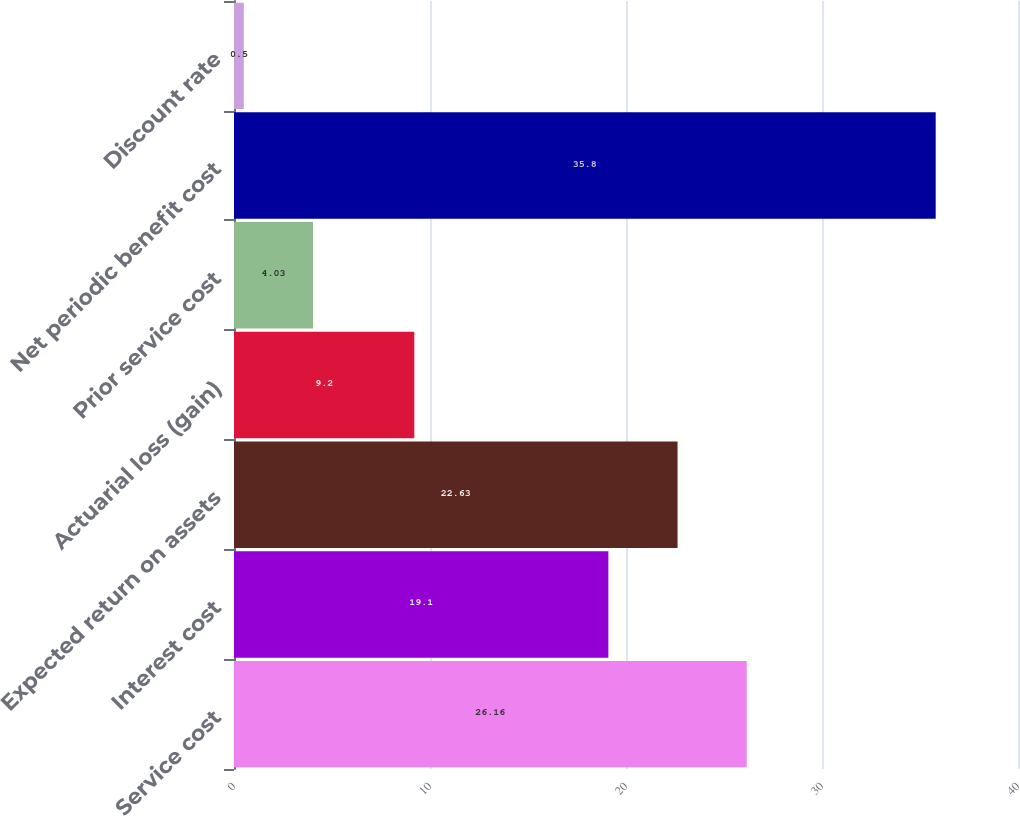Convert chart to OTSL. <chart><loc_0><loc_0><loc_500><loc_500><bar_chart><fcel>Service cost<fcel>Interest cost<fcel>Expected return on assets<fcel>Actuarial loss (gain)<fcel>Prior service cost<fcel>Net periodic benefit cost<fcel>Discount rate<nl><fcel>26.16<fcel>19.1<fcel>22.63<fcel>9.2<fcel>4.03<fcel>35.8<fcel>0.5<nl></chart> 